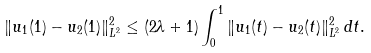<formula> <loc_0><loc_0><loc_500><loc_500>\| u _ { 1 } ( 1 ) - u _ { 2 } ( 1 ) \| _ { L ^ { 2 } } ^ { 2 } \leq ( 2 \lambda + 1 ) \int _ { 0 } ^ { 1 } \| u _ { 1 } ( t ) - u _ { 2 } ( t ) \| _ { L ^ { 2 } } ^ { 2 } \, d t .</formula> 